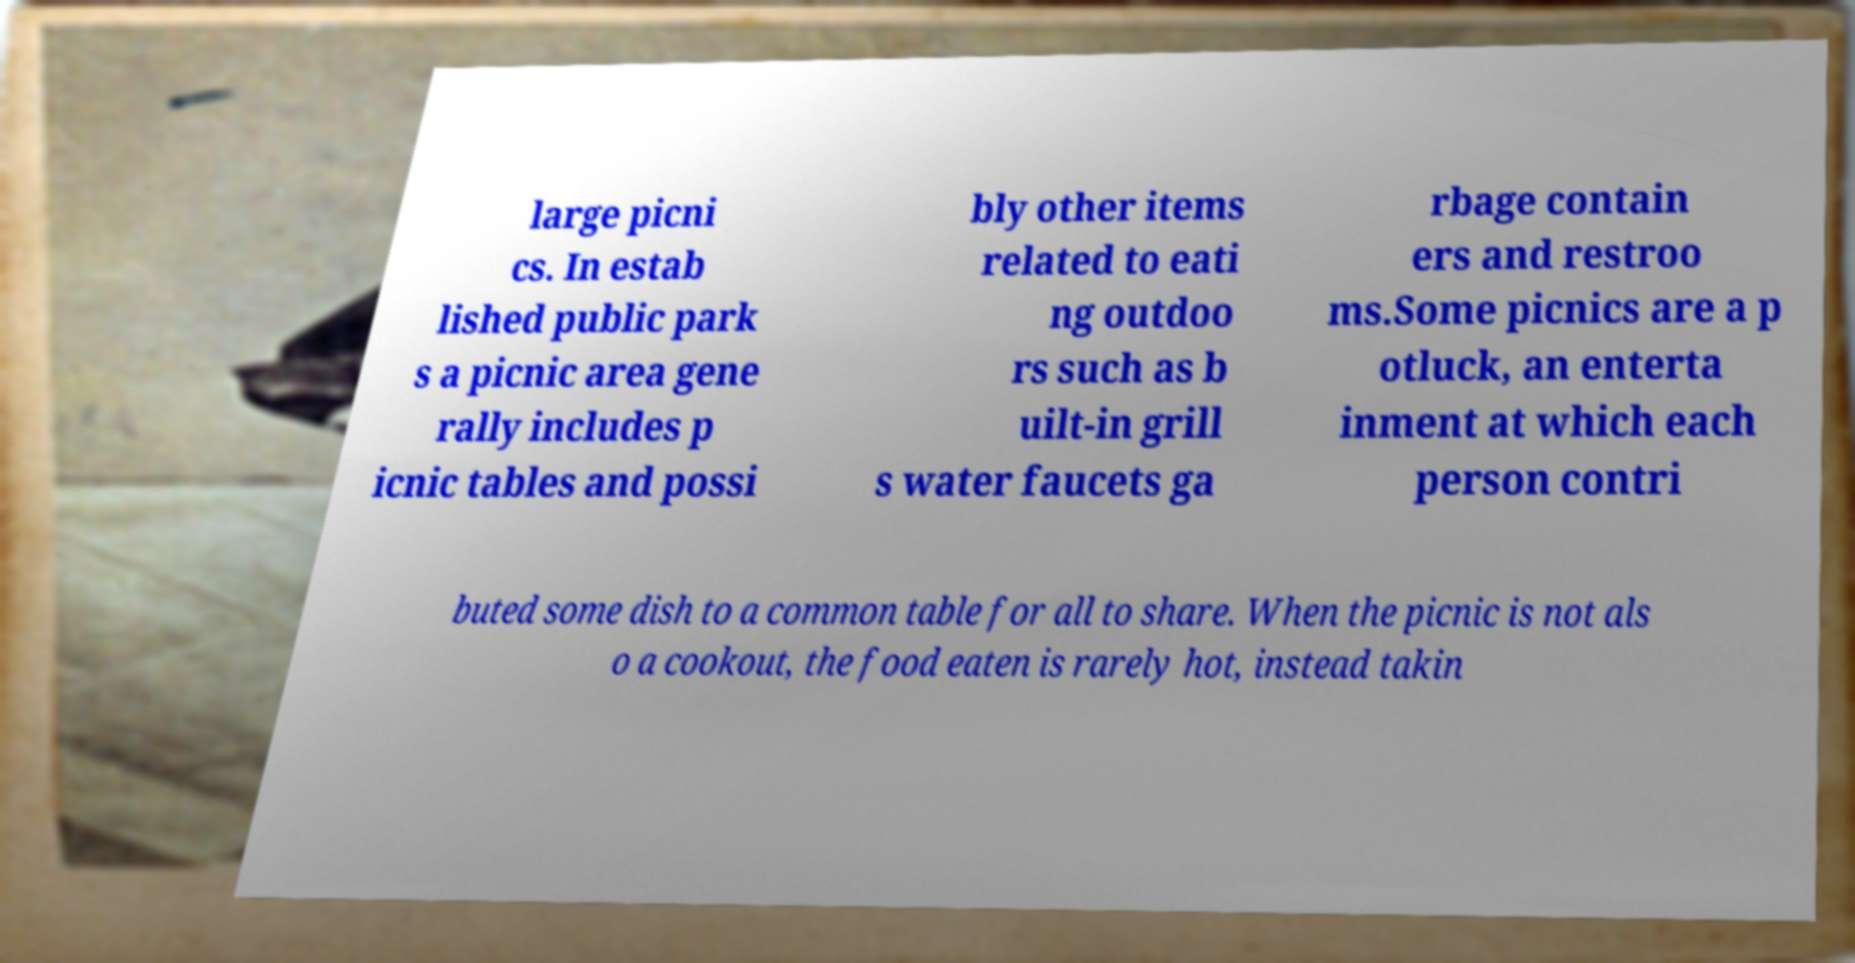Can you read and provide the text displayed in the image?This photo seems to have some interesting text. Can you extract and type it out for me? large picni cs. In estab lished public park s a picnic area gene rally includes p icnic tables and possi bly other items related to eati ng outdoo rs such as b uilt-in grill s water faucets ga rbage contain ers and restroo ms.Some picnics are a p otluck, an enterta inment at which each person contri buted some dish to a common table for all to share. When the picnic is not als o a cookout, the food eaten is rarely hot, instead takin 